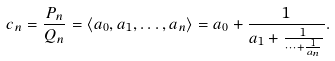<formula> <loc_0><loc_0><loc_500><loc_500>c _ { n } = \frac { P _ { n } } { Q _ { n } } = \langle a _ { 0 } , a _ { 1 } , \dots , a _ { n } \rangle = a _ { 0 } + \frac { 1 } { a _ { 1 } + \frac { 1 } { \dots + \frac { 1 } { a _ { n } } } } .</formula> 